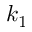<formula> <loc_0><loc_0><loc_500><loc_500>k _ { 1 }</formula> 